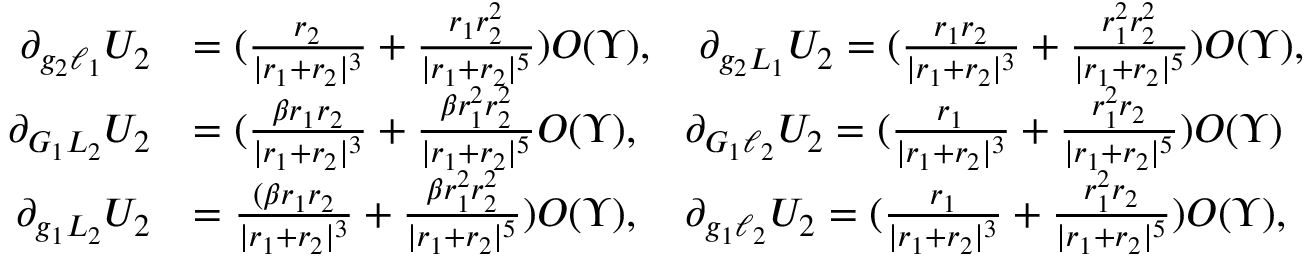Convert formula to latex. <formula><loc_0><loc_0><loc_500><loc_500>\begin{array} { r l } { \partial _ { g _ { 2 } \ell _ { 1 } } U _ { 2 } } & { = ( \frac { r _ { 2 } } { | r _ { 1 } + r _ { 2 } | ^ { 3 } } + \frac { r _ { 1 } r _ { 2 } ^ { 2 } } { | r _ { 1 } + r _ { 2 } | ^ { 5 } } ) O ( \Upsilon ) , \quad \partial _ { g _ { 2 } L _ { 1 } } U _ { 2 } = ( \frac { r _ { 1 } r _ { 2 } } { | r _ { 1 } + r _ { 2 } | ^ { 3 } } + \frac { r _ { 1 } ^ { 2 } r _ { 2 } ^ { 2 } } { | r _ { 1 } + r _ { 2 } | ^ { 5 } } ) O ( \Upsilon ) , } \\ { \partial _ { G _ { 1 } L _ { 2 } } U _ { 2 } } & { = ( \frac { \beta r _ { 1 } r _ { 2 } } { | r _ { 1 } + r _ { 2 } | ^ { 3 } } + \frac { \beta r _ { 1 } ^ { 2 } r _ { 2 } ^ { 2 } } { | r _ { 1 } + r _ { 2 } | ^ { 5 } } O ( \Upsilon ) , \quad \partial _ { G _ { 1 } \ell _ { 2 } } U _ { 2 } = ( \frac { r _ { 1 } } { | r _ { 1 } + r _ { 2 } | ^ { 3 } } + \frac { r _ { 1 } ^ { 2 } r _ { 2 } } { | r _ { 1 } + r _ { 2 } | ^ { 5 } } ) O ( \Upsilon ) } \\ { \partial _ { g _ { 1 } L _ { 2 } } U _ { 2 } } & { = \frac { ( \beta r _ { 1 } r _ { 2 } } { | r _ { 1 } + r _ { 2 } | ^ { 3 } } + \frac { \beta r _ { 1 } ^ { 2 } r _ { 2 } ^ { 2 } } { | r _ { 1 } + r _ { 2 } | ^ { 5 } } ) O ( \Upsilon ) , \quad \partial _ { g _ { 1 } \ell _ { 2 } } U _ { 2 } = ( \frac { r _ { 1 } } { | r _ { 1 } + r _ { 2 } | ^ { 3 } } + \frac { r _ { 1 } ^ { 2 } r _ { 2 } } { | r _ { 1 } + r _ { 2 } | ^ { 5 } } ) O ( \Upsilon ) , } \end{array}</formula> 